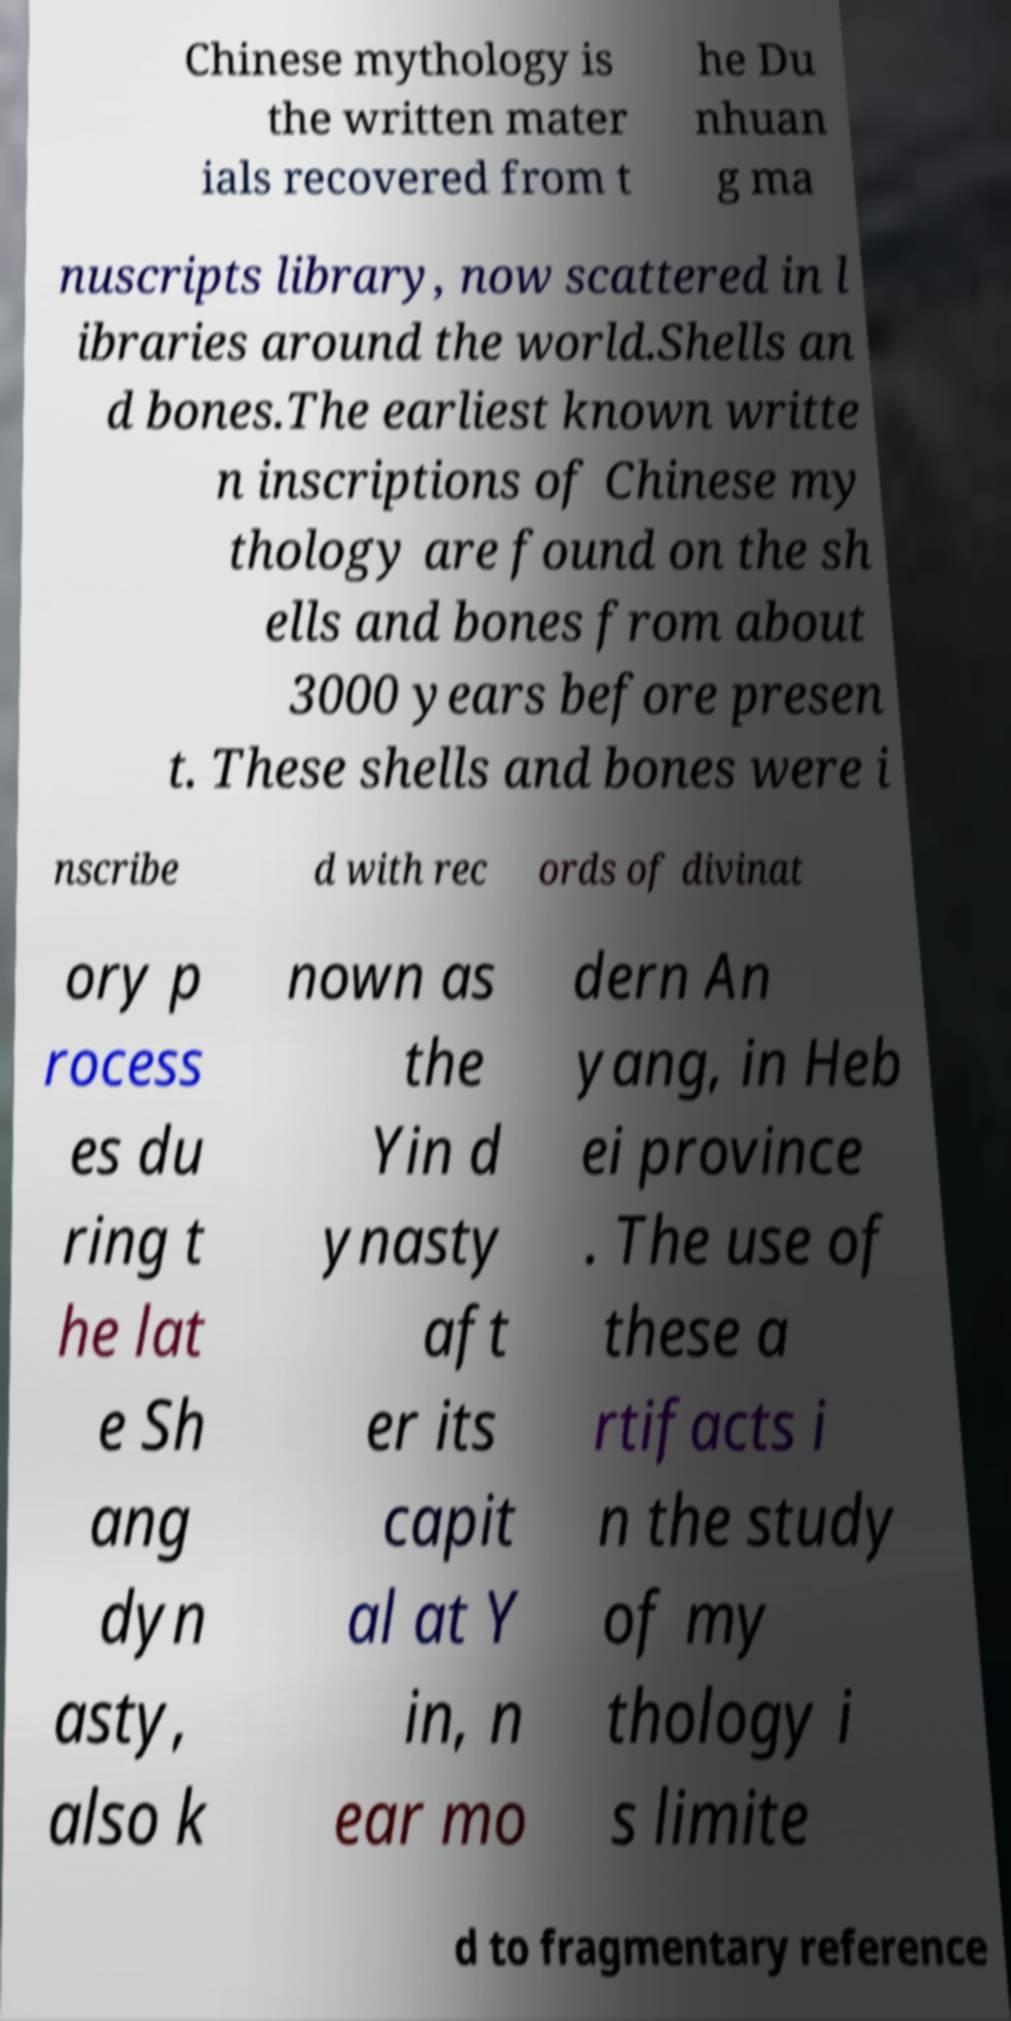Can you accurately transcribe the text from the provided image for me? Chinese mythology is the written mater ials recovered from t he Du nhuan g ma nuscripts library, now scattered in l ibraries around the world.Shells an d bones.The earliest known writte n inscriptions of Chinese my thology are found on the sh ells and bones from about 3000 years before presen t. These shells and bones were i nscribe d with rec ords of divinat ory p rocess es du ring t he lat e Sh ang dyn asty, also k nown as the Yin d ynasty aft er its capit al at Y in, n ear mo dern An yang, in Heb ei province . The use of these a rtifacts i n the study of my thology i s limite d to fragmentary reference 